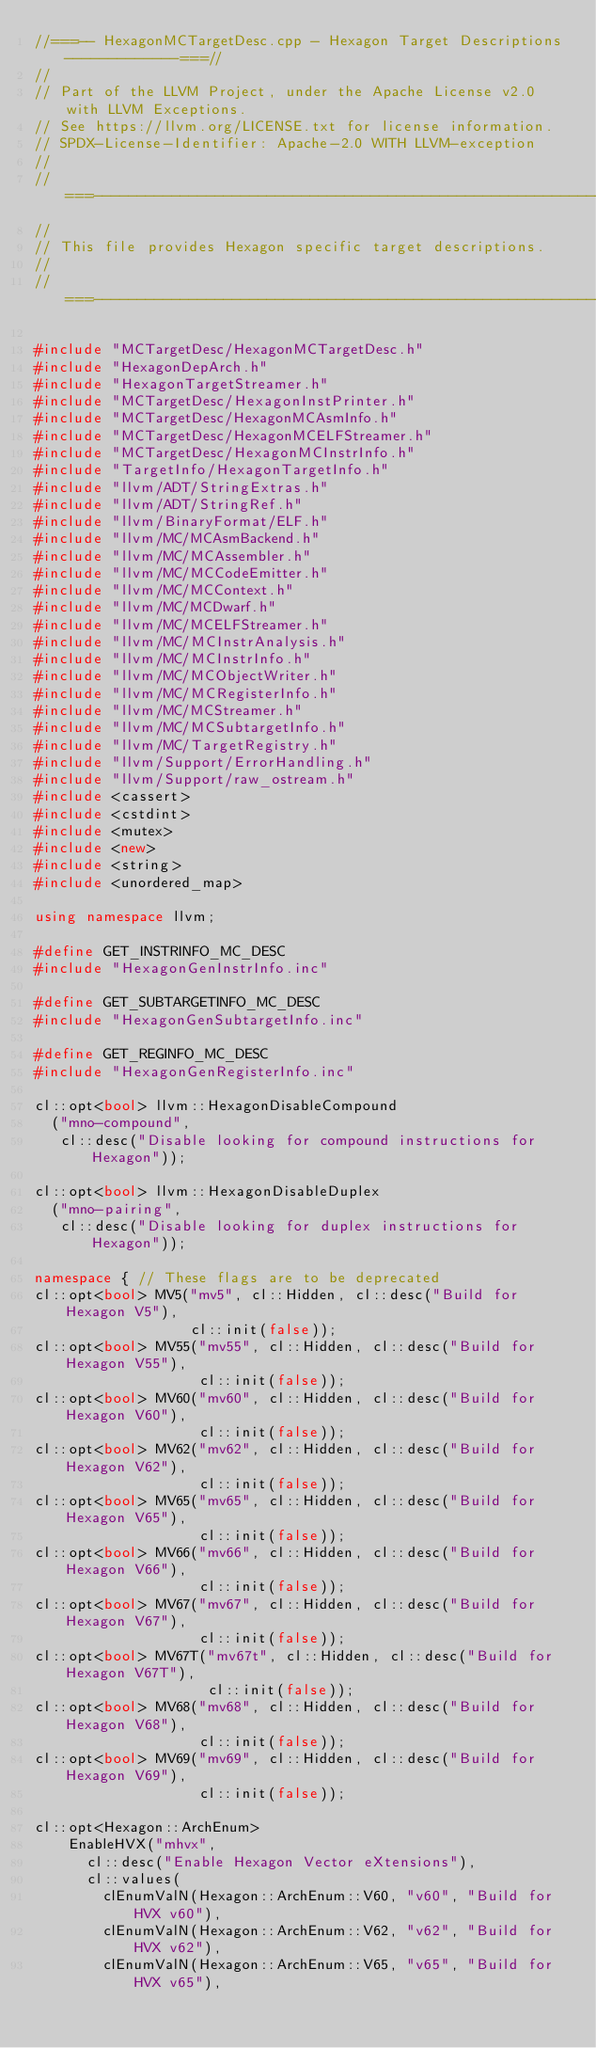Convert code to text. <code><loc_0><loc_0><loc_500><loc_500><_C++_>//===-- HexagonMCTargetDesc.cpp - Hexagon Target Descriptions -------------===//
//
// Part of the LLVM Project, under the Apache License v2.0 with LLVM Exceptions.
// See https://llvm.org/LICENSE.txt for license information.
// SPDX-License-Identifier: Apache-2.0 WITH LLVM-exception
//
//===----------------------------------------------------------------------===//
//
// This file provides Hexagon specific target descriptions.
//
//===----------------------------------------------------------------------===//

#include "MCTargetDesc/HexagonMCTargetDesc.h"
#include "HexagonDepArch.h"
#include "HexagonTargetStreamer.h"
#include "MCTargetDesc/HexagonInstPrinter.h"
#include "MCTargetDesc/HexagonMCAsmInfo.h"
#include "MCTargetDesc/HexagonMCELFStreamer.h"
#include "MCTargetDesc/HexagonMCInstrInfo.h"
#include "TargetInfo/HexagonTargetInfo.h"
#include "llvm/ADT/StringExtras.h"
#include "llvm/ADT/StringRef.h"
#include "llvm/BinaryFormat/ELF.h"
#include "llvm/MC/MCAsmBackend.h"
#include "llvm/MC/MCAssembler.h"
#include "llvm/MC/MCCodeEmitter.h"
#include "llvm/MC/MCContext.h"
#include "llvm/MC/MCDwarf.h"
#include "llvm/MC/MCELFStreamer.h"
#include "llvm/MC/MCInstrAnalysis.h"
#include "llvm/MC/MCInstrInfo.h"
#include "llvm/MC/MCObjectWriter.h"
#include "llvm/MC/MCRegisterInfo.h"
#include "llvm/MC/MCStreamer.h"
#include "llvm/MC/MCSubtargetInfo.h"
#include "llvm/MC/TargetRegistry.h"
#include "llvm/Support/ErrorHandling.h"
#include "llvm/Support/raw_ostream.h"
#include <cassert>
#include <cstdint>
#include <mutex>
#include <new>
#include <string>
#include <unordered_map>

using namespace llvm;

#define GET_INSTRINFO_MC_DESC
#include "HexagonGenInstrInfo.inc"

#define GET_SUBTARGETINFO_MC_DESC
#include "HexagonGenSubtargetInfo.inc"

#define GET_REGINFO_MC_DESC
#include "HexagonGenRegisterInfo.inc"

cl::opt<bool> llvm::HexagonDisableCompound
  ("mno-compound",
   cl::desc("Disable looking for compound instructions for Hexagon"));

cl::opt<bool> llvm::HexagonDisableDuplex
  ("mno-pairing",
   cl::desc("Disable looking for duplex instructions for Hexagon"));

namespace { // These flags are to be deprecated
cl::opt<bool> MV5("mv5", cl::Hidden, cl::desc("Build for Hexagon V5"),
                  cl::init(false));
cl::opt<bool> MV55("mv55", cl::Hidden, cl::desc("Build for Hexagon V55"),
                   cl::init(false));
cl::opt<bool> MV60("mv60", cl::Hidden, cl::desc("Build for Hexagon V60"),
                   cl::init(false));
cl::opt<bool> MV62("mv62", cl::Hidden, cl::desc("Build for Hexagon V62"),
                   cl::init(false));
cl::opt<bool> MV65("mv65", cl::Hidden, cl::desc("Build for Hexagon V65"),
                   cl::init(false));
cl::opt<bool> MV66("mv66", cl::Hidden, cl::desc("Build for Hexagon V66"),
                   cl::init(false));
cl::opt<bool> MV67("mv67", cl::Hidden, cl::desc("Build for Hexagon V67"),
                   cl::init(false));
cl::opt<bool> MV67T("mv67t", cl::Hidden, cl::desc("Build for Hexagon V67T"),
                    cl::init(false));
cl::opt<bool> MV68("mv68", cl::Hidden, cl::desc("Build for Hexagon V68"),
                   cl::init(false));
cl::opt<bool> MV69("mv69", cl::Hidden, cl::desc("Build for Hexagon V69"),
                   cl::init(false));

cl::opt<Hexagon::ArchEnum>
    EnableHVX("mhvx",
      cl::desc("Enable Hexagon Vector eXtensions"),
      cl::values(
        clEnumValN(Hexagon::ArchEnum::V60, "v60", "Build for HVX v60"),
        clEnumValN(Hexagon::ArchEnum::V62, "v62", "Build for HVX v62"),
        clEnumValN(Hexagon::ArchEnum::V65, "v65", "Build for HVX v65"),</code> 